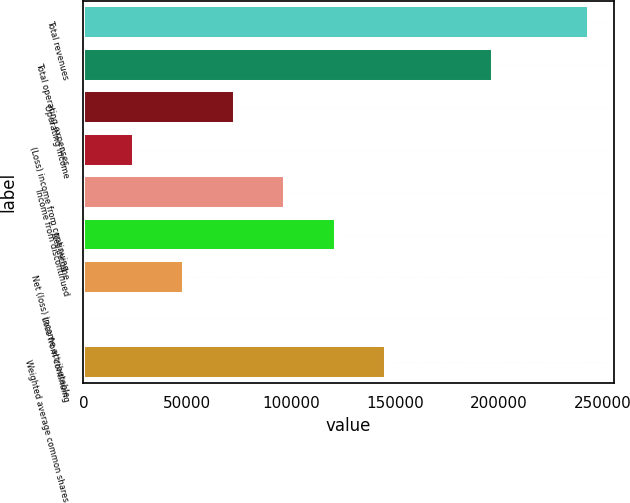<chart> <loc_0><loc_0><loc_500><loc_500><bar_chart><fcel>Total revenues<fcel>Total operating expenses<fcel>Operating income<fcel>(Loss) income from continuing<fcel>Income from discontinued<fcel>Net income<fcel>Net (loss) income attributable<fcel>Loss from continuing<fcel>Weighted average common shares<nl><fcel>242973<fcel>197071<fcel>72891.9<fcel>24297.4<fcel>97189.2<fcel>121487<fcel>48594.7<fcel>0.07<fcel>145784<nl></chart> 